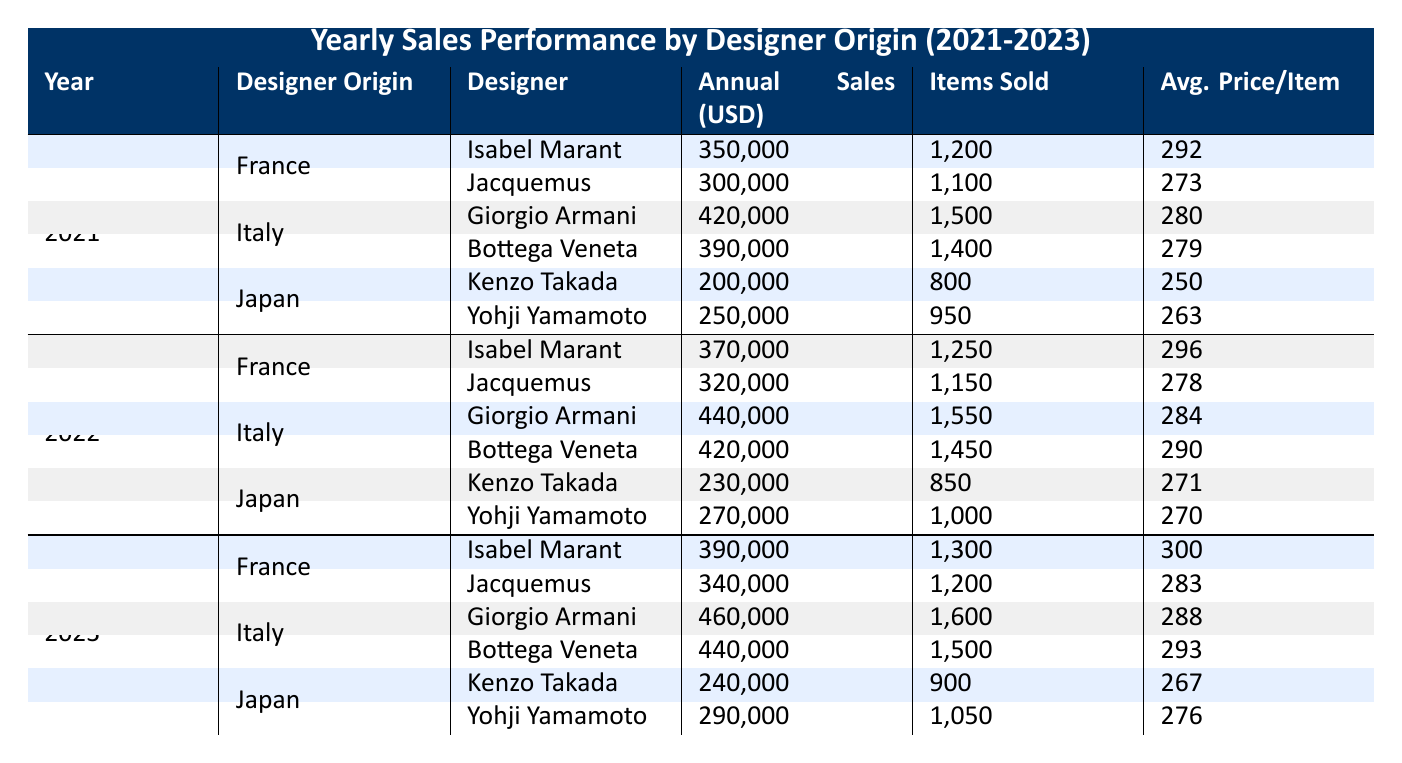What were the annual sales for Isabel Marant in 2022? In the table, we can see the row for France in 2022, where Isabel Marant is listed. Her annual sales for that year are specifically noted as 370,000.
Answer: 370000 Which designer had the highest sales in Italy in 2023? In the Italy section for 2023, we compare the annual sales figures for both designers. Giorgio Armani's sales were 460,000, while Bottega Veneta's were 440,000. Since 460,000 is greater than 440,000, Giorgio Armani had the highest sales.
Answer: Giorgio Armani What is the average annual sales of Japanese designers over the three years? We need to add up the annual sales for Japanese designers across all years: (Kenzo Takada: 200,000 + 250,000 + 240,000) + (Yohji Yamamoto: 250,000 + 270,000 + 290,000) = 1,740,000 in total. There are 6 data points (2 designers over 3 years), so the average is 1,740,000 / 6 = 290,000.
Answer: 290000 Did Jacquemus' sales increase from 2021 to 2023? Looking at the sales figures for Jacquemus, we see 300,000 in 2021, 320,000 in 2022, and 340,000 in 2023. Since each value is higher than the one before, we conclude that sales increased over the years.
Answer: Yes Which origin had the lowest total sales in 2021? We sum the sales for each designer's origin in 2021: France (350,000 + 300,000 = 650,000), Italy (420,000 + 390,000 = 810,000), Japan (200,000 + 250,000 = 450,000). Japan's total sales of 450,000 are the lowest compared to the other origins.
Answer: Japan 